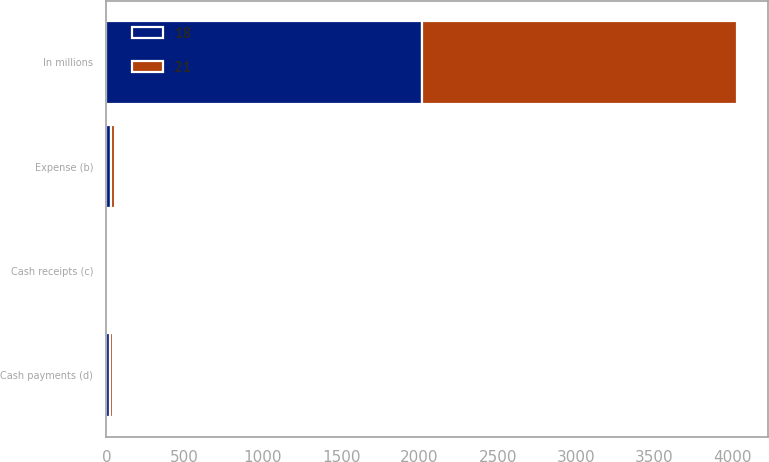<chart> <loc_0><loc_0><loc_500><loc_500><stacked_bar_chart><ecel><fcel>In millions<fcel>Expense (b)<fcel>Cash receipts (c)<fcel>Cash payments (d)<nl><fcel>21<fcel>2015<fcel>27<fcel>7<fcel>18<nl><fcel>18<fcel>2013<fcel>29<fcel>8<fcel>21<nl></chart> 